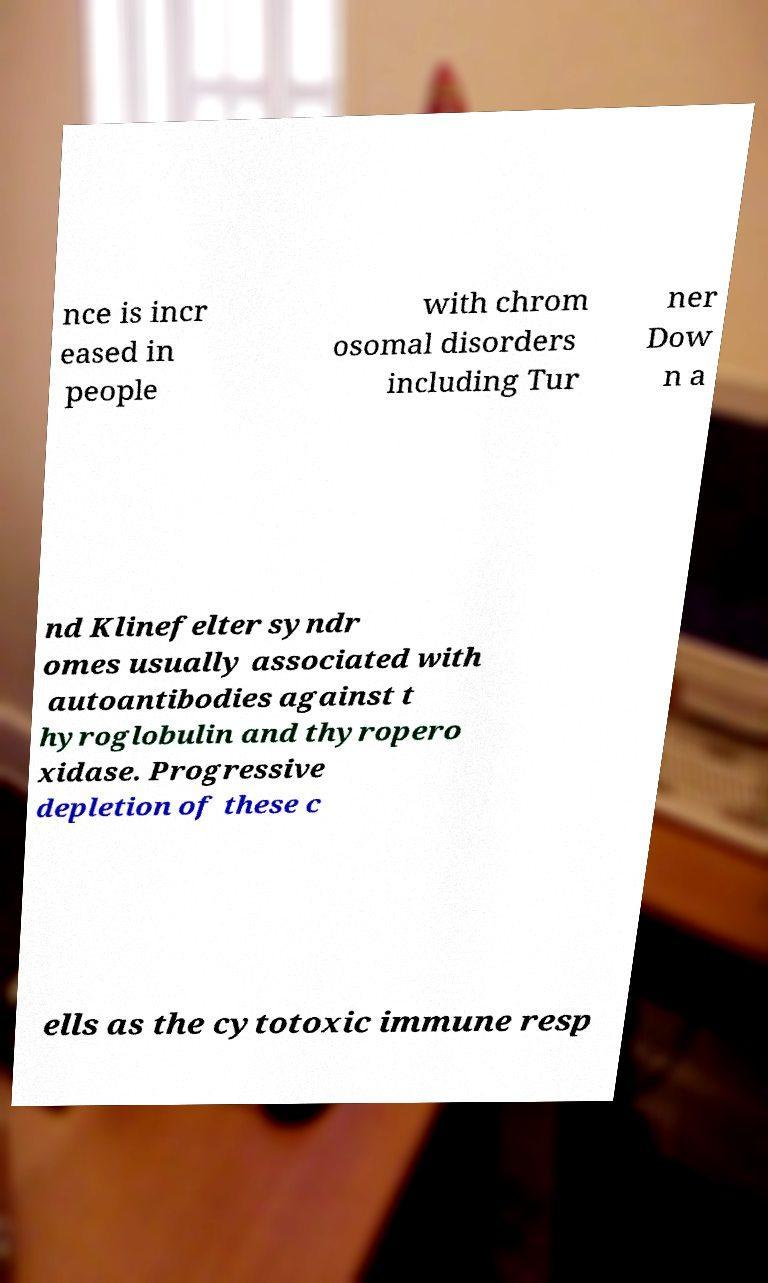There's text embedded in this image that I need extracted. Can you transcribe it verbatim? nce is incr eased in people with chrom osomal disorders including Tur ner Dow n a nd Klinefelter syndr omes usually associated with autoantibodies against t hyroglobulin and thyropero xidase. Progressive depletion of these c ells as the cytotoxic immune resp 